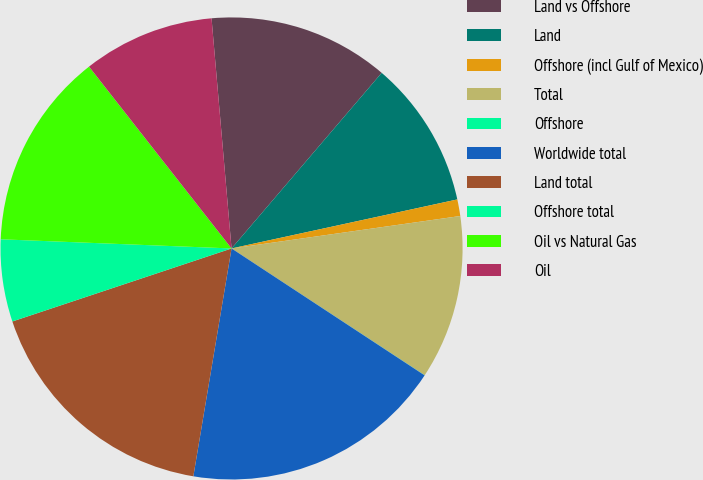Convert chart. <chart><loc_0><loc_0><loc_500><loc_500><pie_chart><fcel>Land vs Offshore<fcel>Land<fcel>Offshore (incl Gulf of Mexico)<fcel>Total<fcel>Offshore<fcel>Worldwide total<fcel>Land total<fcel>Offshore total<fcel>Oil vs Natural Gas<fcel>Oil<nl><fcel>12.64%<fcel>10.34%<fcel>1.16%<fcel>11.49%<fcel>0.01%<fcel>18.39%<fcel>17.24%<fcel>5.75%<fcel>13.79%<fcel>9.2%<nl></chart> 